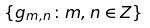Convert formula to latex. <formula><loc_0><loc_0><loc_500><loc_500>\{ g _ { m , n } \colon m , n \in Z \}</formula> 